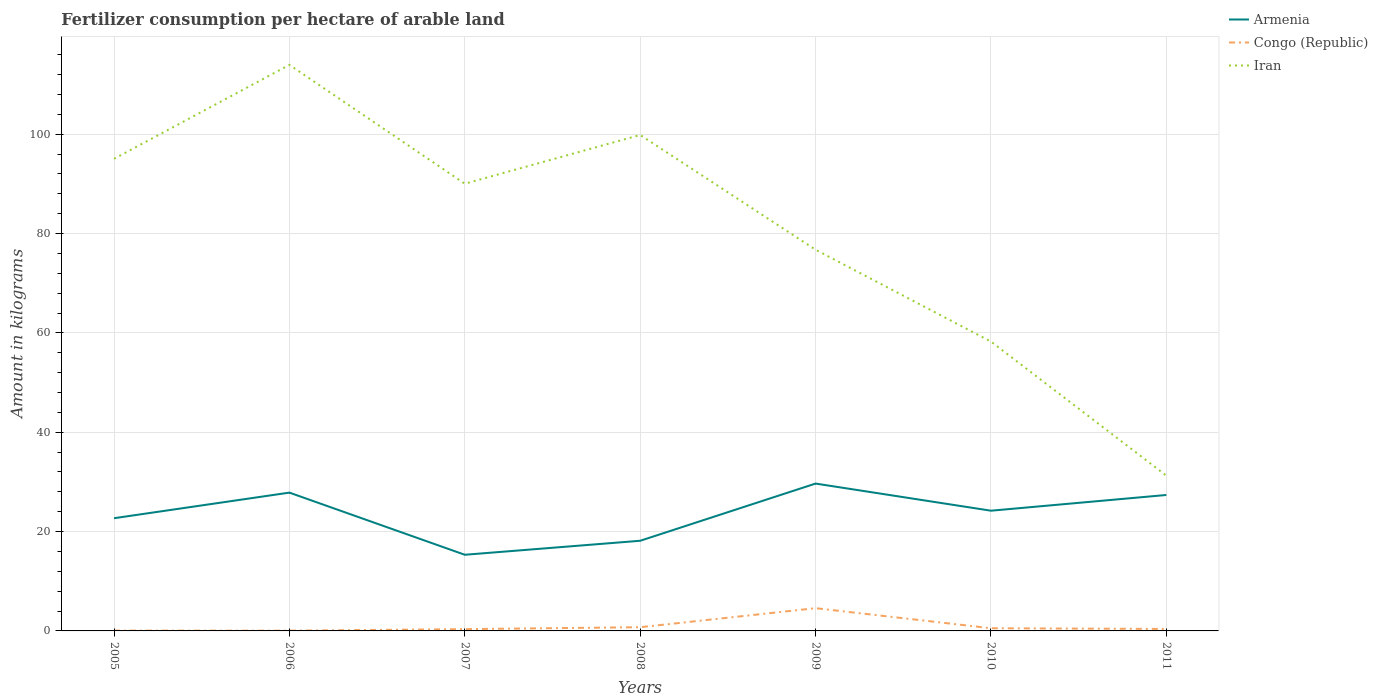Does the line corresponding to Iran intersect with the line corresponding to Armenia?
Ensure brevity in your answer.  No. Is the number of lines equal to the number of legend labels?
Ensure brevity in your answer.  Yes. Across all years, what is the maximum amount of fertilizer consumption in Iran?
Make the answer very short. 31.26. What is the total amount of fertilizer consumption in Congo (Republic) in the graph?
Ensure brevity in your answer.  -4.51. What is the difference between the highest and the second highest amount of fertilizer consumption in Iran?
Give a very brief answer. 82.7. What is the difference between the highest and the lowest amount of fertilizer consumption in Congo (Republic)?
Provide a short and direct response. 1. Is the amount of fertilizer consumption in Armenia strictly greater than the amount of fertilizer consumption in Congo (Republic) over the years?
Offer a very short reply. No. What is the difference between two consecutive major ticks on the Y-axis?
Make the answer very short. 20. Does the graph contain any zero values?
Your answer should be compact. No. Does the graph contain grids?
Provide a short and direct response. Yes. How many legend labels are there?
Your answer should be compact. 3. What is the title of the graph?
Offer a terse response. Fertilizer consumption per hectare of arable land. What is the label or title of the X-axis?
Your answer should be very brief. Years. What is the label or title of the Y-axis?
Keep it short and to the point. Amount in kilograms. What is the Amount in kilograms of Armenia in 2005?
Your answer should be compact. 22.69. What is the Amount in kilograms in Congo (Republic) in 2005?
Make the answer very short. 0.07. What is the Amount in kilograms of Iran in 2005?
Make the answer very short. 95.05. What is the Amount in kilograms of Armenia in 2006?
Provide a succinct answer. 27.84. What is the Amount in kilograms in Congo (Republic) in 2006?
Provide a short and direct response. 0.05. What is the Amount in kilograms of Iran in 2006?
Ensure brevity in your answer.  113.96. What is the Amount in kilograms in Armenia in 2007?
Offer a very short reply. 15.33. What is the Amount in kilograms in Congo (Republic) in 2007?
Ensure brevity in your answer.  0.36. What is the Amount in kilograms in Iran in 2007?
Provide a succinct answer. 90.04. What is the Amount in kilograms in Armenia in 2008?
Keep it short and to the point. 18.15. What is the Amount in kilograms of Congo (Republic) in 2008?
Provide a short and direct response. 0.75. What is the Amount in kilograms of Iran in 2008?
Provide a short and direct response. 99.85. What is the Amount in kilograms in Armenia in 2009?
Your answer should be very brief. 29.67. What is the Amount in kilograms in Congo (Republic) in 2009?
Your response must be concise. 4.58. What is the Amount in kilograms of Iran in 2009?
Ensure brevity in your answer.  76.74. What is the Amount in kilograms in Armenia in 2010?
Provide a short and direct response. 24.2. What is the Amount in kilograms of Congo (Republic) in 2010?
Keep it short and to the point. 0.54. What is the Amount in kilograms of Iran in 2010?
Your answer should be compact. 58.25. What is the Amount in kilograms in Armenia in 2011?
Make the answer very short. 27.37. What is the Amount in kilograms in Congo (Republic) in 2011?
Offer a terse response. 0.4. What is the Amount in kilograms in Iran in 2011?
Ensure brevity in your answer.  31.26. Across all years, what is the maximum Amount in kilograms of Armenia?
Give a very brief answer. 29.67. Across all years, what is the maximum Amount in kilograms of Congo (Republic)?
Give a very brief answer. 4.58. Across all years, what is the maximum Amount in kilograms of Iran?
Provide a succinct answer. 113.96. Across all years, what is the minimum Amount in kilograms of Armenia?
Give a very brief answer. 15.33. Across all years, what is the minimum Amount in kilograms in Congo (Republic)?
Provide a succinct answer. 0.05. Across all years, what is the minimum Amount in kilograms in Iran?
Give a very brief answer. 31.26. What is the total Amount in kilograms in Armenia in the graph?
Make the answer very short. 165.26. What is the total Amount in kilograms of Congo (Republic) in the graph?
Your answer should be very brief. 6.74. What is the total Amount in kilograms in Iran in the graph?
Provide a short and direct response. 565.15. What is the difference between the Amount in kilograms in Armenia in 2005 and that in 2006?
Give a very brief answer. -5.15. What is the difference between the Amount in kilograms of Congo (Republic) in 2005 and that in 2006?
Your answer should be compact. 0.01. What is the difference between the Amount in kilograms of Iran in 2005 and that in 2006?
Your answer should be compact. -18.91. What is the difference between the Amount in kilograms in Armenia in 2005 and that in 2007?
Keep it short and to the point. 7.36. What is the difference between the Amount in kilograms of Congo (Republic) in 2005 and that in 2007?
Make the answer very short. -0.29. What is the difference between the Amount in kilograms in Iran in 2005 and that in 2007?
Your answer should be compact. 5.01. What is the difference between the Amount in kilograms of Armenia in 2005 and that in 2008?
Provide a short and direct response. 4.54. What is the difference between the Amount in kilograms in Congo (Republic) in 2005 and that in 2008?
Your answer should be very brief. -0.68. What is the difference between the Amount in kilograms in Iran in 2005 and that in 2008?
Your answer should be very brief. -4.8. What is the difference between the Amount in kilograms in Armenia in 2005 and that in 2009?
Your answer should be compact. -6.97. What is the difference between the Amount in kilograms of Congo (Republic) in 2005 and that in 2009?
Make the answer very short. -4.51. What is the difference between the Amount in kilograms of Iran in 2005 and that in 2009?
Your answer should be very brief. 18.3. What is the difference between the Amount in kilograms in Armenia in 2005 and that in 2010?
Give a very brief answer. -1.51. What is the difference between the Amount in kilograms in Congo (Republic) in 2005 and that in 2010?
Offer a terse response. -0.48. What is the difference between the Amount in kilograms in Iran in 2005 and that in 2010?
Provide a succinct answer. 36.8. What is the difference between the Amount in kilograms in Armenia in 2005 and that in 2011?
Offer a terse response. -4.68. What is the difference between the Amount in kilograms in Congo (Republic) in 2005 and that in 2011?
Your answer should be very brief. -0.33. What is the difference between the Amount in kilograms in Iran in 2005 and that in 2011?
Your answer should be compact. 63.79. What is the difference between the Amount in kilograms of Armenia in 2006 and that in 2007?
Provide a succinct answer. 12.51. What is the difference between the Amount in kilograms in Congo (Republic) in 2006 and that in 2007?
Make the answer very short. -0.31. What is the difference between the Amount in kilograms of Iran in 2006 and that in 2007?
Provide a short and direct response. 23.92. What is the difference between the Amount in kilograms in Armenia in 2006 and that in 2008?
Your answer should be very brief. 9.69. What is the difference between the Amount in kilograms of Congo (Republic) in 2006 and that in 2008?
Provide a succinct answer. -0.69. What is the difference between the Amount in kilograms in Iran in 2006 and that in 2008?
Provide a succinct answer. 14.11. What is the difference between the Amount in kilograms of Armenia in 2006 and that in 2009?
Keep it short and to the point. -1.82. What is the difference between the Amount in kilograms of Congo (Republic) in 2006 and that in 2009?
Provide a short and direct response. -4.52. What is the difference between the Amount in kilograms in Iran in 2006 and that in 2009?
Offer a very short reply. 37.22. What is the difference between the Amount in kilograms in Armenia in 2006 and that in 2010?
Your answer should be very brief. 3.64. What is the difference between the Amount in kilograms in Congo (Republic) in 2006 and that in 2010?
Your response must be concise. -0.49. What is the difference between the Amount in kilograms of Iran in 2006 and that in 2010?
Your answer should be compact. 55.71. What is the difference between the Amount in kilograms in Armenia in 2006 and that in 2011?
Provide a succinct answer. 0.48. What is the difference between the Amount in kilograms in Congo (Republic) in 2006 and that in 2011?
Your answer should be very brief. -0.34. What is the difference between the Amount in kilograms in Iran in 2006 and that in 2011?
Give a very brief answer. 82.7. What is the difference between the Amount in kilograms in Armenia in 2007 and that in 2008?
Make the answer very short. -2.82. What is the difference between the Amount in kilograms of Congo (Republic) in 2007 and that in 2008?
Provide a short and direct response. -0.39. What is the difference between the Amount in kilograms of Iran in 2007 and that in 2008?
Give a very brief answer. -9.81. What is the difference between the Amount in kilograms of Armenia in 2007 and that in 2009?
Your response must be concise. -14.33. What is the difference between the Amount in kilograms in Congo (Republic) in 2007 and that in 2009?
Ensure brevity in your answer.  -4.22. What is the difference between the Amount in kilograms in Iran in 2007 and that in 2009?
Your answer should be very brief. 13.29. What is the difference between the Amount in kilograms of Armenia in 2007 and that in 2010?
Make the answer very short. -8.87. What is the difference between the Amount in kilograms in Congo (Republic) in 2007 and that in 2010?
Keep it short and to the point. -0.18. What is the difference between the Amount in kilograms of Iran in 2007 and that in 2010?
Your answer should be very brief. 31.79. What is the difference between the Amount in kilograms of Armenia in 2007 and that in 2011?
Give a very brief answer. -12.04. What is the difference between the Amount in kilograms of Congo (Republic) in 2007 and that in 2011?
Offer a terse response. -0.04. What is the difference between the Amount in kilograms in Iran in 2007 and that in 2011?
Give a very brief answer. 58.78. What is the difference between the Amount in kilograms of Armenia in 2008 and that in 2009?
Offer a very short reply. -11.52. What is the difference between the Amount in kilograms of Congo (Republic) in 2008 and that in 2009?
Provide a succinct answer. -3.83. What is the difference between the Amount in kilograms of Iran in 2008 and that in 2009?
Offer a very short reply. 23.1. What is the difference between the Amount in kilograms of Armenia in 2008 and that in 2010?
Provide a short and direct response. -6.05. What is the difference between the Amount in kilograms of Congo (Republic) in 2008 and that in 2010?
Provide a short and direct response. 0.21. What is the difference between the Amount in kilograms of Iran in 2008 and that in 2010?
Give a very brief answer. 41.6. What is the difference between the Amount in kilograms in Armenia in 2008 and that in 2011?
Your response must be concise. -9.22. What is the difference between the Amount in kilograms in Congo (Republic) in 2008 and that in 2011?
Your response must be concise. 0.35. What is the difference between the Amount in kilograms in Iran in 2008 and that in 2011?
Offer a very short reply. 68.59. What is the difference between the Amount in kilograms in Armenia in 2009 and that in 2010?
Ensure brevity in your answer.  5.46. What is the difference between the Amount in kilograms in Congo (Republic) in 2009 and that in 2010?
Keep it short and to the point. 4.04. What is the difference between the Amount in kilograms of Iran in 2009 and that in 2010?
Keep it short and to the point. 18.49. What is the difference between the Amount in kilograms in Armenia in 2009 and that in 2011?
Provide a succinct answer. 2.3. What is the difference between the Amount in kilograms of Congo (Republic) in 2009 and that in 2011?
Make the answer very short. 4.18. What is the difference between the Amount in kilograms in Iran in 2009 and that in 2011?
Keep it short and to the point. 45.48. What is the difference between the Amount in kilograms in Armenia in 2010 and that in 2011?
Your answer should be compact. -3.17. What is the difference between the Amount in kilograms in Congo (Republic) in 2010 and that in 2011?
Your answer should be very brief. 0.14. What is the difference between the Amount in kilograms of Iran in 2010 and that in 2011?
Offer a very short reply. 26.99. What is the difference between the Amount in kilograms in Armenia in 2005 and the Amount in kilograms in Congo (Republic) in 2006?
Offer a terse response. 22.64. What is the difference between the Amount in kilograms of Armenia in 2005 and the Amount in kilograms of Iran in 2006?
Offer a very short reply. -91.27. What is the difference between the Amount in kilograms of Congo (Republic) in 2005 and the Amount in kilograms of Iran in 2006?
Offer a terse response. -113.9. What is the difference between the Amount in kilograms in Armenia in 2005 and the Amount in kilograms in Congo (Republic) in 2007?
Your response must be concise. 22.33. What is the difference between the Amount in kilograms in Armenia in 2005 and the Amount in kilograms in Iran in 2007?
Make the answer very short. -67.35. What is the difference between the Amount in kilograms in Congo (Republic) in 2005 and the Amount in kilograms in Iran in 2007?
Ensure brevity in your answer.  -89.97. What is the difference between the Amount in kilograms in Armenia in 2005 and the Amount in kilograms in Congo (Republic) in 2008?
Your answer should be very brief. 21.95. What is the difference between the Amount in kilograms in Armenia in 2005 and the Amount in kilograms in Iran in 2008?
Your answer should be compact. -77.15. What is the difference between the Amount in kilograms of Congo (Republic) in 2005 and the Amount in kilograms of Iran in 2008?
Your answer should be very brief. -99.78. What is the difference between the Amount in kilograms of Armenia in 2005 and the Amount in kilograms of Congo (Republic) in 2009?
Your response must be concise. 18.11. What is the difference between the Amount in kilograms of Armenia in 2005 and the Amount in kilograms of Iran in 2009?
Provide a short and direct response. -54.05. What is the difference between the Amount in kilograms in Congo (Republic) in 2005 and the Amount in kilograms in Iran in 2009?
Ensure brevity in your answer.  -76.68. What is the difference between the Amount in kilograms of Armenia in 2005 and the Amount in kilograms of Congo (Republic) in 2010?
Offer a terse response. 22.15. What is the difference between the Amount in kilograms in Armenia in 2005 and the Amount in kilograms in Iran in 2010?
Ensure brevity in your answer.  -35.56. What is the difference between the Amount in kilograms of Congo (Republic) in 2005 and the Amount in kilograms of Iran in 2010?
Your response must be concise. -58.18. What is the difference between the Amount in kilograms of Armenia in 2005 and the Amount in kilograms of Congo (Republic) in 2011?
Your response must be concise. 22.3. What is the difference between the Amount in kilograms of Armenia in 2005 and the Amount in kilograms of Iran in 2011?
Make the answer very short. -8.57. What is the difference between the Amount in kilograms of Congo (Republic) in 2005 and the Amount in kilograms of Iran in 2011?
Offer a terse response. -31.19. What is the difference between the Amount in kilograms in Armenia in 2006 and the Amount in kilograms in Congo (Republic) in 2007?
Offer a very short reply. 27.49. What is the difference between the Amount in kilograms in Armenia in 2006 and the Amount in kilograms in Iran in 2007?
Keep it short and to the point. -62.19. What is the difference between the Amount in kilograms of Congo (Republic) in 2006 and the Amount in kilograms of Iran in 2007?
Your answer should be very brief. -89.99. What is the difference between the Amount in kilograms of Armenia in 2006 and the Amount in kilograms of Congo (Republic) in 2008?
Give a very brief answer. 27.1. What is the difference between the Amount in kilograms in Armenia in 2006 and the Amount in kilograms in Iran in 2008?
Offer a terse response. -72. What is the difference between the Amount in kilograms of Congo (Republic) in 2006 and the Amount in kilograms of Iran in 2008?
Give a very brief answer. -99.79. What is the difference between the Amount in kilograms of Armenia in 2006 and the Amount in kilograms of Congo (Republic) in 2009?
Give a very brief answer. 23.27. What is the difference between the Amount in kilograms of Armenia in 2006 and the Amount in kilograms of Iran in 2009?
Make the answer very short. -48.9. What is the difference between the Amount in kilograms in Congo (Republic) in 2006 and the Amount in kilograms in Iran in 2009?
Your answer should be compact. -76.69. What is the difference between the Amount in kilograms of Armenia in 2006 and the Amount in kilograms of Congo (Republic) in 2010?
Offer a very short reply. 27.3. What is the difference between the Amount in kilograms in Armenia in 2006 and the Amount in kilograms in Iran in 2010?
Make the answer very short. -30.4. What is the difference between the Amount in kilograms of Congo (Republic) in 2006 and the Amount in kilograms of Iran in 2010?
Make the answer very short. -58.2. What is the difference between the Amount in kilograms in Armenia in 2006 and the Amount in kilograms in Congo (Republic) in 2011?
Keep it short and to the point. 27.45. What is the difference between the Amount in kilograms in Armenia in 2006 and the Amount in kilograms in Iran in 2011?
Ensure brevity in your answer.  -3.42. What is the difference between the Amount in kilograms of Congo (Republic) in 2006 and the Amount in kilograms of Iran in 2011?
Your answer should be compact. -31.21. What is the difference between the Amount in kilograms of Armenia in 2007 and the Amount in kilograms of Congo (Republic) in 2008?
Offer a terse response. 14.59. What is the difference between the Amount in kilograms in Armenia in 2007 and the Amount in kilograms in Iran in 2008?
Your answer should be very brief. -84.51. What is the difference between the Amount in kilograms of Congo (Republic) in 2007 and the Amount in kilograms of Iran in 2008?
Make the answer very short. -99.49. What is the difference between the Amount in kilograms in Armenia in 2007 and the Amount in kilograms in Congo (Republic) in 2009?
Ensure brevity in your answer.  10.75. What is the difference between the Amount in kilograms in Armenia in 2007 and the Amount in kilograms in Iran in 2009?
Your answer should be very brief. -61.41. What is the difference between the Amount in kilograms in Congo (Republic) in 2007 and the Amount in kilograms in Iran in 2009?
Your response must be concise. -76.39. What is the difference between the Amount in kilograms in Armenia in 2007 and the Amount in kilograms in Congo (Republic) in 2010?
Ensure brevity in your answer.  14.79. What is the difference between the Amount in kilograms in Armenia in 2007 and the Amount in kilograms in Iran in 2010?
Keep it short and to the point. -42.92. What is the difference between the Amount in kilograms in Congo (Republic) in 2007 and the Amount in kilograms in Iran in 2010?
Ensure brevity in your answer.  -57.89. What is the difference between the Amount in kilograms in Armenia in 2007 and the Amount in kilograms in Congo (Republic) in 2011?
Provide a succinct answer. 14.94. What is the difference between the Amount in kilograms in Armenia in 2007 and the Amount in kilograms in Iran in 2011?
Make the answer very short. -15.93. What is the difference between the Amount in kilograms of Congo (Republic) in 2007 and the Amount in kilograms of Iran in 2011?
Provide a short and direct response. -30.9. What is the difference between the Amount in kilograms in Armenia in 2008 and the Amount in kilograms in Congo (Republic) in 2009?
Offer a terse response. 13.57. What is the difference between the Amount in kilograms of Armenia in 2008 and the Amount in kilograms of Iran in 2009?
Provide a short and direct response. -58.59. What is the difference between the Amount in kilograms in Congo (Republic) in 2008 and the Amount in kilograms in Iran in 2009?
Your answer should be very brief. -76. What is the difference between the Amount in kilograms of Armenia in 2008 and the Amount in kilograms of Congo (Republic) in 2010?
Provide a short and direct response. 17.61. What is the difference between the Amount in kilograms in Armenia in 2008 and the Amount in kilograms in Iran in 2010?
Provide a short and direct response. -40.1. What is the difference between the Amount in kilograms of Congo (Republic) in 2008 and the Amount in kilograms of Iran in 2010?
Your answer should be very brief. -57.5. What is the difference between the Amount in kilograms in Armenia in 2008 and the Amount in kilograms in Congo (Republic) in 2011?
Provide a succinct answer. 17.75. What is the difference between the Amount in kilograms in Armenia in 2008 and the Amount in kilograms in Iran in 2011?
Offer a very short reply. -13.11. What is the difference between the Amount in kilograms of Congo (Republic) in 2008 and the Amount in kilograms of Iran in 2011?
Ensure brevity in your answer.  -30.51. What is the difference between the Amount in kilograms in Armenia in 2009 and the Amount in kilograms in Congo (Republic) in 2010?
Ensure brevity in your answer.  29.12. What is the difference between the Amount in kilograms of Armenia in 2009 and the Amount in kilograms of Iran in 2010?
Make the answer very short. -28.58. What is the difference between the Amount in kilograms of Congo (Republic) in 2009 and the Amount in kilograms of Iran in 2010?
Ensure brevity in your answer.  -53.67. What is the difference between the Amount in kilograms in Armenia in 2009 and the Amount in kilograms in Congo (Republic) in 2011?
Offer a very short reply. 29.27. What is the difference between the Amount in kilograms of Armenia in 2009 and the Amount in kilograms of Iran in 2011?
Your answer should be compact. -1.59. What is the difference between the Amount in kilograms in Congo (Republic) in 2009 and the Amount in kilograms in Iran in 2011?
Offer a terse response. -26.68. What is the difference between the Amount in kilograms in Armenia in 2010 and the Amount in kilograms in Congo (Republic) in 2011?
Offer a very short reply. 23.81. What is the difference between the Amount in kilograms of Armenia in 2010 and the Amount in kilograms of Iran in 2011?
Give a very brief answer. -7.06. What is the difference between the Amount in kilograms of Congo (Republic) in 2010 and the Amount in kilograms of Iran in 2011?
Your answer should be compact. -30.72. What is the average Amount in kilograms of Armenia per year?
Your answer should be very brief. 23.61. What is the average Amount in kilograms in Congo (Republic) per year?
Offer a very short reply. 0.96. What is the average Amount in kilograms in Iran per year?
Offer a terse response. 80.74. In the year 2005, what is the difference between the Amount in kilograms in Armenia and Amount in kilograms in Congo (Republic)?
Offer a very short reply. 22.63. In the year 2005, what is the difference between the Amount in kilograms in Armenia and Amount in kilograms in Iran?
Give a very brief answer. -72.36. In the year 2005, what is the difference between the Amount in kilograms of Congo (Republic) and Amount in kilograms of Iran?
Your response must be concise. -94.98. In the year 2006, what is the difference between the Amount in kilograms in Armenia and Amount in kilograms in Congo (Republic)?
Give a very brief answer. 27.79. In the year 2006, what is the difference between the Amount in kilograms of Armenia and Amount in kilograms of Iran?
Make the answer very short. -86.12. In the year 2006, what is the difference between the Amount in kilograms of Congo (Republic) and Amount in kilograms of Iran?
Your answer should be very brief. -113.91. In the year 2007, what is the difference between the Amount in kilograms in Armenia and Amount in kilograms in Congo (Republic)?
Provide a short and direct response. 14.97. In the year 2007, what is the difference between the Amount in kilograms of Armenia and Amount in kilograms of Iran?
Ensure brevity in your answer.  -74.71. In the year 2007, what is the difference between the Amount in kilograms in Congo (Republic) and Amount in kilograms in Iran?
Provide a succinct answer. -89.68. In the year 2008, what is the difference between the Amount in kilograms of Armenia and Amount in kilograms of Congo (Republic)?
Your answer should be compact. 17.4. In the year 2008, what is the difference between the Amount in kilograms of Armenia and Amount in kilograms of Iran?
Your response must be concise. -81.7. In the year 2008, what is the difference between the Amount in kilograms in Congo (Republic) and Amount in kilograms in Iran?
Make the answer very short. -99.1. In the year 2009, what is the difference between the Amount in kilograms in Armenia and Amount in kilograms in Congo (Republic)?
Your answer should be very brief. 25.09. In the year 2009, what is the difference between the Amount in kilograms in Armenia and Amount in kilograms in Iran?
Keep it short and to the point. -47.08. In the year 2009, what is the difference between the Amount in kilograms of Congo (Republic) and Amount in kilograms of Iran?
Your answer should be very brief. -72.17. In the year 2010, what is the difference between the Amount in kilograms in Armenia and Amount in kilograms in Congo (Republic)?
Your response must be concise. 23.66. In the year 2010, what is the difference between the Amount in kilograms of Armenia and Amount in kilograms of Iran?
Provide a succinct answer. -34.05. In the year 2010, what is the difference between the Amount in kilograms of Congo (Republic) and Amount in kilograms of Iran?
Offer a terse response. -57.71. In the year 2011, what is the difference between the Amount in kilograms in Armenia and Amount in kilograms in Congo (Republic)?
Make the answer very short. 26.97. In the year 2011, what is the difference between the Amount in kilograms of Armenia and Amount in kilograms of Iran?
Offer a very short reply. -3.89. In the year 2011, what is the difference between the Amount in kilograms in Congo (Republic) and Amount in kilograms in Iran?
Make the answer very short. -30.86. What is the ratio of the Amount in kilograms in Armenia in 2005 to that in 2006?
Offer a very short reply. 0.81. What is the ratio of the Amount in kilograms in Congo (Republic) in 2005 to that in 2006?
Offer a terse response. 1.23. What is the ratio of the Amount in kilograms of Iran in 2005 to that in 2006?
Provide a succinct answer. 0.83. What is the ratio of the Amount in kilograms of Armenia in 2005 to that in 2007?
Ensure brevity in your answer.  1.48. What is the ratio of the Amount in kilograms in Congo (Republic) in 2005 to that in 2007?
Give a very brief answer. 0.18. What is the ratio of the Amount in kilograms in Iran in 2005 to that in 2007?
Ensure brevity in your answer.  1.06. What is the ratio of the Amount in kilograms of Armenia in 2005 to that in 2008?
Give a very brief answer. 1.25. What is the ratio of the Amount in kilograms of Congo (Republic) in 2005 to that in 2008?
Your answer should be compact. 0.09. What is the ratio of the Amount in kilograms of Iran in 2005 to that in 2008?
Provide a succinct answer. 0.95. What is the ratio of the Amount in kilograms in Armenia in 2005 to that in 2009?
Ensure brevity in your answer.  0.76. What is the ratio of the Amount in kilograms in Congo (Republic) in 2005 to that in 2009?
Your answer should be very brief. 0.01. What is the ratio of the Amount in kilograms in Iran in 2005 to that in 2009?
Your answer should be very brief. 1.24. What is the ratio of the Amount in kilograms of Armenia in 2005 to that in 2010?
Your response must be concise. 0.94. What is the ratio of the Amount in kilograms in Congo (Republic) in 2005 to that in 2010?
Ensure brevity in your answer.  0.12. What is the ratio of the Amount in kilograms of Iran in 2005 to that in 2010?
Ensure brevity in your answer.  1.63. What is the ratio of the Amount in kilograms in Armenia in 2005 to that in 2011?
Your response must be concise. 0.83. What is the ratio of the Amount in kilograms of Congo (Republic) in 2005 to that in 2011?
Provide a succinct answer. 0.16. What is the ratio of the Amount in kilograms in Iran in 2005 to that in 2011?
Offer a very short reply. 3.04. What is the ratio of the Amount in kilograms of Armenia in 2006 to that in 2007?
Your answer should be very brief. 1.82. What is the ratio of the Amount in kilograms of Congo (Republic) in 2006 to that in 2007?
Your answer should be compact. 0.15. What is the ratio of the Amount in kilograms in Iran in 2006 to that in 2007?
Offer a very short reply. 1.27. What is the ratio of the Amount in kilograms of Armenia in 2006 to that in 2008?
Provide a short and direct response. 1.53. What is the ratio of the Amount in kilograms in Congo (Republic) in 2006 to that in 2008?
Keep it short and to the point. 0.07. What is the ratio of the Amount in kilograms in Iran in 2006 to that in 2008?
Your answer should be compact. 1.14. What is the ratio of the Amount in kilograms of Armenia in 2006 to that in 2009?
Ensure brevity in your answer.  0.94. What is the ratio of the Amount in kilograms in Congo (Republic) in 2006 to that in 2009?
Give a very brief answer. 0.01. What is the ratio of the Amount in kilograms in Iran in 2006 to that in 2009?
Provide a short and direct response. 1.49. What is the ratio of the Amount in kilograms in Armenia in 2006 to that in 2010?
Ensure brevity in your answer.  1.15. What is the ratio of the Amount in kilograms of Congo (Republic) in 2006 to that in 2010?
Keep it short and to the point. 0.1. What is the ratio of the Amount in kilograms of Iran in 2006 to that in 2010?
Offer a terse response. 1.96. What is the ratio of the Amount in kilograms of Armenia in 2006 to that in 2011?
Keep it short and to the point. 1.02. What is the ratio of the Amount in kilograms of Congo (Republic) in 2006 to that in 2011?
Ensure brevity in your answer.  0.13. What is the ratio of the Amount in kilograms of Iran in 2006 to that in 2011?
Give a very brief answer. 3.65. What is the ratio of the Amount in kilograms of Armenia in 2007 to that in 2008?
Provide a short and direct response. 0.84. What is the ratio of the Amount in kilograms in Congo (Republic) in 2007 to that in 2008?
Make the answer very short. 0.48. What is the ratio of the Amount in kilograms in Iran in 2007 to that in 2008?
Give a very brief answer. 0.9. What is the ratio of the Amount in kilograms in Armenia in 2007 to that in 2009?
Your response must be concise. 0.52. What is the ratio of the Amount in kilograms in Congo (Republic) in 2007 to that in 2009?
Your answer should be compact. 0.08. What is the ratio of the Amount in kilograms of Iran in 2007 to that in 2009?
Offer a very short reply. 1.17. What is the ratio of the Amount in kilograms of Armenia in 2007 to that in 2010?
Make the answer very short. 0.63. What is the ratio of the Amount in kilograms of Congo (Republic) in 2007 to that in 2010?
Provide a short and direct response. 0.66. What is the ratio of the Amount in kilograms in Iran in 2007 to that in 2010?
Your answer should be very brief. 1.55. What is the ratio of the Amount in kilograms of Armenia in 2007 to that in 2011?
Your response must be concise. 0.56. What is the ratio of the Amount in kilograms of Congo (Republic) in 2007 to that in 2011?
Make the answer very short. 0.91. What is the ratio of the Amount in kilograms of Iran in 2007 to that in 2011?
Give a very brief answer. 2.88. What is the ratio of the Amount in kilograms of Armenia in 2008 to that in 2009?
Keep it short and to the point. 0.61. What is the ratio of the Amount in kilograms in Congo (Republic) in 2008 to that in 2009?
Provide a short and direct response. 0.16. What is the ratio of the Amount in kilograms of Iran in 2008 to that in 2009?
Make the answer very short. 1.3. What is the ratio of the Amount in kilograms of Armenia in 2008 to that in 2010?
Make the answer very short. 0.75. What is the ratio of the Amount in kilograms of Congo (Republic) in 2008 to that in 2010?
Provide a short and direct response. 1.38. What is the ratio of the Amount in kilograms in Iran in 2008 to that in 2010?
Give a very brief answer. 1.71. What is the ratio of the Amount in kilograms in Armenia in 2008 to that in 2011?
Your answer should be very brief. 0.66. What is the ratio of the Amount in kilograms in Congo (Republic) in 2008 to that in 2011?
Your answer should be very brief. 1.89. What is the ratio of the Amount in kilograms in Iran in 2008 to that in 2011?
Give a very brief answer. 3.19. What is the ratio of the Amount in kilograms in Armenia in 2009 to that in 2010?
Provide a succinct answer. 1.23. What is the ratio of the Amount in kilograms in Congo (Republic) in 2009 to that in 2010?
Ensure brevity in your answer.  8.46. What is the ratio of the Amount in kilograms in Iran in 2009 to that in 2010?
Offer a very short reply. 1.32. What is the ratio of the Amount in kilograms in Armenia in 2009 to that in 2011?
Ensure brevity in your answer.  1.08. What is the ratio of the Amount in kilograms in Congo (Republic) in 2009 to that in 2011?
Provide a short and direct response. 11.55. What is the ratio of the Amount in kilograms in Iran in 2009 to that in 2011?
Provide a succinct answer. 2.46. What is the ratio of the Amount in kilograms in Armenia in 2010 to that in 2011?
Give a very brief answer. 0.88. What is the ratio of the Amount in kilograms in Congo (Republic) in 2010 to that in 2011?
Give a very brief answer. 1.37. What is the ratio of the Amount in kilograms of Iran in 2010 to that in 2011?
Give a very brief answer. 1.86. What is the difference between the highest and the second highest Amount in kilograms of Armenia?
Your response must be concise. 1.82. What is the difference between the highest and the second highest Amount in kilograms in Congo (Republic)?
Provide a short and direct response. 3.83. What is the difference between the highest and the second highest Amount in kilograms in Iran?
Give a very brief answer. 14.11. What is the difference between the highest and the lowest Amount in kilograms in Armenia?
Ensure brevity in your answer.  14.33. What is the difference between the highest and the lowest Amount in kilograms of Congo (Republic)?
Ensure brevity in your answer.  4.52. What is the difference between the highest and the lowest Amount in kilograms of Iran?
Your answer should be compact. 82.7. 